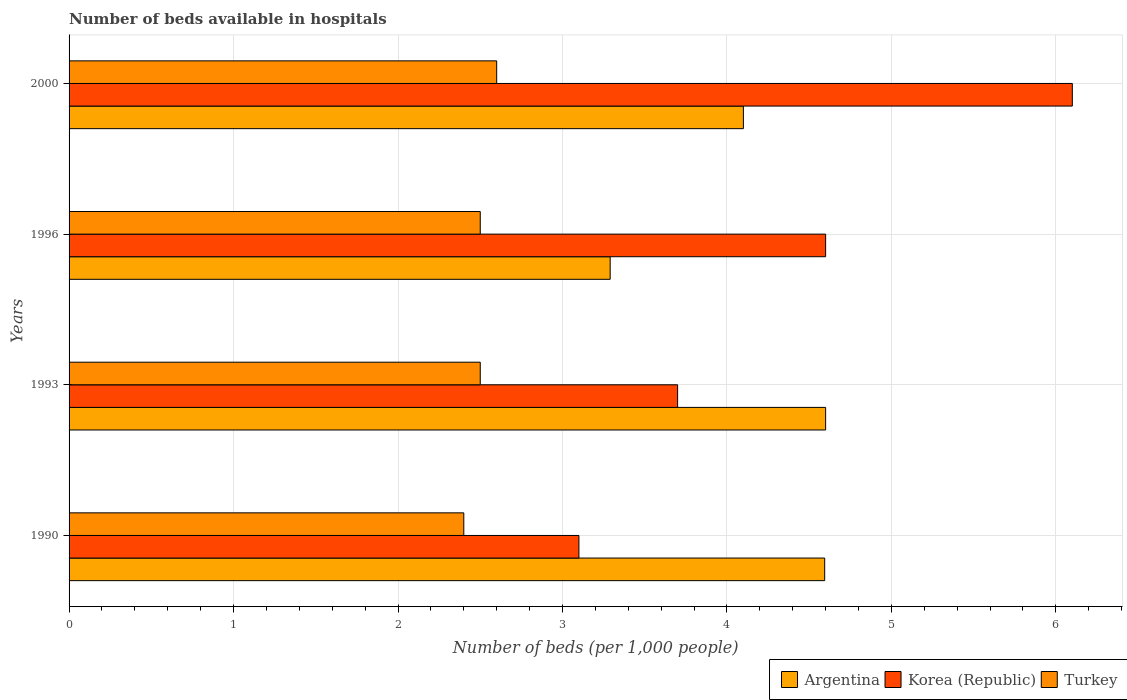Are the number of bars on each tick of the Y-axis equal?
Provide a succinct answer. Yes. How many bars are there on the 2nd tick from the bottom?
Your answer should be compact. 3. What is the label of the 1st group of bars from the top?
Offer a very short reply. 2000. In how many cases, is the number of bars for a given year not equal to the number of legend labels?
Give a very brief answer. 0. What is the number of beds in the hospiatls of in Korea (Republic) in 1993?
Your response must be concise. 3.7. Across all years, what is the maximum number of beds in the hospiatls of in Korea (Republic)?
Give a very brief answer. 6.1. Across all years, what is the minimum number of beds in the hospiatls of in Korea (Republic)?
Offer a very short reply. 3.1. In which year was the number of beds in the hospiatls of in Turkey maximum?
Offer a very short reply. 2000. In which year was the number of beds in the hospiatls of in Turkey minimum?
Offer a terse response. 1990. What is the total number of beds in the hospiatls of in Turkey in the graph?
Your answer should be compact. 10. What is the difference between the number of beds in the hospiatls of in Korea (Republic) in 1993 and that in 2000?
Offer a terse response. -2.4. What is the difference between the number of beds in the hospiatls of in Korea (Republic) in 1993 and the number of beds in the hospiatls of in Turkey in 2000?
Your response must be concise. 1.1. What is the average number of beds in the hospiatls of in Korea (Republic) per year?
Keep it short and to the point. 4.37. In the year 1996, what is the difference between the number of beds in the hospiatls of in Turkey and number of beds in the hospiatls of in Argentina?
Provide a succinct answer. -0.79. In how many years, is the number of beds in the hospiatls of in Argentina greater than 3.8 ?
Keep it short and to the point. 3. What is the ratio of the number of beds in the hospiatls of in Turkey in 1990 to that in 1993?
Your answer should be compact. 0.96. Is the difference between the number of beds in the hospiatls of in Turkey in 1990 and 1993 greater than the difference between the number of beds in the hospiatls of in Argentina in 1990 and 1993?
Ensure brevity in your answer.  No. What is the difference between the highest and the second highest number of beds in the hospiatls of in Korea (Republic)?
Provide a succinct answer. 1.5. What is the difference between the highest and the lowest number of beds in the hospiatls of in Korea (Republic)?
Ensure brevity in your answer.  3. Is the sum of the number of beds in the hospiatls of in Korea (Republic) in 1990 and 1996 greater than the maximum number of beds in the hospiatls of in Argentina across all years?
Your response must be concise. Yes. What does the 3rd bar from the top in 1993 represents?
Offer a very short reply. Argentina. What does the 1st bar from the bottom in 1990 represents?
Provide a succinct answer. Argentina. Is it the case that in every year, the sum of the number of beds in the hospiatls of in Korea (Republic) and number of beds in the hospiatls of in Turkey is greater than the number of beds in the hospiatls of in Argentina?
Provide a succinct answer. Yes. How many bars are there?
Keep it short and to the point. 12. What is the difference between two consecutive major ticks on the X-axis?
Ensure brevity in your answer.  1. Where does the legend appear in the graph?
Provide a short and direct response. Bottom right. How many legend labels are there?
Give a very brief answer. 3. How are the legend labels stacked?
Ensure brevity in your answer.  Horizontal. What is the title of the graph?
Your answer should be compact. Number of beds available in hospitals. Does "United Arab Emirates" appear as one of the legend labels in the graph?
Keep it short and to the point. No. What is the label or title of the X-axis?
Your response must be concise. Number of beds (per 1,0 people). What is the label or title of the Y-axis?
Provide a succinct answer. Years. What is the Number of beds (per 1,000 people) of Argentina in 1990?
Ensure brevity in your answer.  4.59. What is the Number of beds (per 1,000 people) in Korea (Republic) in 1990?
Give a very brief answer. 3.1. What is the Number of beds (per 1,000 people) of Turkey in 1990?
Your response must be concise. 2.4. What is the Number of beds (per 1,000 people) in Argentina in 1993?
Make the answer very short. 4.6. What is the Number of beds (per 1,000 people) of Korea (Republic) in 1993?
Ensure brevity in your answer.  3.7. What is the Number of beds (per 1,000 people) in Argentina in 1996?
Make the answer very short. 3.29. What is the Number of beds (per 1,000 people) of Korea (Republic) in 1996?
Ensure brevity in your answer.  4.6. What is the Number of beds (per 1,000 people) in Turkey in 1996?
Give a very brief answer. 2.5. What is the Number of beds (per 1,000 people) of Korea (Republic) in 2000?
Ensure brevity in your answer.  6.1. What is the Number of beds (per 1,000 people) in Turkey in 2000?
Your answer should be compact. 2.6. Across all years, what is the maximum Number of beds (per 1,000 people) in Argentina?
Your answer should be compact. 4.6. Across all years, what is the maximum Number of beds (per 1,000 people) of Korea (Republic)?
Give a very brief answer. 6.1. Across all years, what is the maximum Number of beds (per 1,000 people) of Turkey?
Your answer should be compact. 2.6. Across all years, what is the minimum Number of beds (per 1,000 people) of Argentina?
Your response must be concise. 3.29. Across all years, what is the minimum Number of beds (per 1,000 people) in Korea (Republic)?
Your answer should be very brief. 3.1. Across all years, what is the minimum Number of beds (per 1,000 people) of Turkey?
Make the answer very short. 2.4. What is the total Number of beds (per 1,000 people) of Argentina in the graph?
Provide a short and direct response. 16.58. What is the difference between the Number of beds (per 1,000 people) in Argentina in 1990 and that in 1993?
Offer a terse response. -0.01. What is the difference between the Number of beds (per 1,000 people) of Korea (Republic) in 1990 and that in 1993?
Provide a succinct answer. -0.6. What is the difference between the Number of beds (per 1,000 people) of Argentina in 1990 and that in 1996?
Your answer should be very brief. 1.3. What is the difference between the Number of beds (per 1,000 people) of Korea (Republic) in 1990 and that in 1996?
Your answer should be compact. -1.5. What is the difference between the Number of beds (per 1,000 people) in Turkey in 1990 and that in 1996?
Provide a short and direct response. -0.1. What is the difference between the Number of beds (per 1,000 people) in Argentina in 1990 and that in 2000?
Ensure brevity in your answer.  0.49. What is the difference between the Number of beds (per 1,000 people) of Argentina in 1993 and that in 1996?
Offer a very short reply. 1.31. What is the difference between the Number of beds (per 1,000 people) in Korea (Republic) in 1993 and that in 1996?
Give a very brief answer. -0.9. What is the difference between the Number of beds (per 1,000 people) in Turkey in 1993 and that in 1996?
Make the answer very short. 0. What is the difference between the Number of beds (per 1,000 people) of Argentina in 1993 and that in 2000?
Ensure brevity in your answer.  0.5. What is the difference between the Number of beds (per 1,000 people) of Korea (Republic) in 1993 and that in 2000?
Keep it short and to the point. -2.4. What is the difference between the Number of beds (per 1,000 people) in Argentina in 1996 and that in 2000?
Your answer should be very brief. -0.81. What is the difference between the Number of beds (per 1,000 people) in Korea (Republic) in 1996 and that in 2000?
Provide a short and direct response. -1.5. What is the difference between the Number of beds (per 1,000 people) of Argentina in 1990 and the Number of beds (per 1,000 people) of Korea (Republic) in 1993?
Offer a very short reply. 0.89. What is the difference between the Number of beds (per 1,000 people) in Argentina in 1990 and the Number of beds (per 1,000 people) in Turkey in 1993?
Offer a very short reply. 2.09. What is the difference between the Number of beds (per 1,000 people) of Argentina in 1990 and the Number of beds (per 1,000 people) of Korea (Republic) in 1996?
Make the answer very short. -0.01. What is the difference between the Number of beds (per 1,000 people) in Argentina in 1990 and the Number of beds (per 1,000 people) in Turkey in 1996?
Make the answer very short. 2.09. What is the difference between the Number of beds (per 1,000 people) in Korea (Republic) in 1990 and the Number of beds (per 1,000 people) in Turkey in 1996?
Offer a very short reply. 0.6. What is the difference between the Number of beds (per 1,000 people) in Argentina in 1990 and the Number of beds (per 1,000 people) in Korea (Republic) in 2000?
Keep it short and to the point. -1.51. What is the difference between the Number of beds (per 1,000 people) in Argentina in 1990 and the Number of beds (per 1,000 people) in Turkey in 2000?
Offer a very short reply. 1.99. What is the difference between the Number of beds (per 1,000 people) in Argentina in 1993 and the Number of beds (per 1,000 people) in Turkey in 1996?
Offer a very short reply. 2.1. What is the difference between the Number of beds (per 1,000 people) in Korea (Republic) in 1993 and the Number of beds (per 1,000 people) in Turkey in 1996?
Your answer should be compact. 1.2. What is the difference between the Number of beds (per 1,000 people) in Argentina in 1993 and the Number of beds (per 1,000 people) in Korea (Republic) in 2000?
Your response must be concise. -1.5. What is the difference between the Number of beds (per 1,000 people) of Korea (Republic) in 1993 and the Number of beds (per 1,000 people) of Turkey in 2000?
Give a very brief answer. 1.1. What is the difference between the Number of beds (per 1,000 people) in Argentina in 1996 and the Number of beds (per 1,000 people) in Korea (Republic) in 2000?
Your response must be concise. -2.81. What is the difference between the Number of beds (per 1,000 people) in Argentina in 1996 and the Number of beds (per 1,000 people) in Turkey in 2000?
Your response must be concise. 0.69. What is the difference between the Number of beds (per 1,000 people) in Korea (Republic) in 1996 and the Number of beds (per 1,000 people) in Turkey in 2000?
Provide a short and direct response. 2. What is the average Number of beds (per 1,000 people) of Argentina per year?
Your answer should be very brief. 4.15. What is the average Number of beds (per 1,000 people) in Korea (Republic) per year?
Make the answer very short. 4.38. In the year 1990, what is the difference between the Number of beds (per 1,000 people) of Argentina and Number of beds (per 1,000 people) of Korea (Republic)?
Provide a short and direct response. 1.49. In the year 1990, what is the difference between the Number of beds (per 1,000 people) of Argentina and Number of beds (per 1,000 people) of Turkey?
Keep it short and to the point. 2.19. In the year 1990, what is the difference between the Number of beds (per 1,000 people) of Korea (Republic) and Number of beds (per 1,000 people) of Turkey?
Make the answer very short. 0.7. In the year 1993, what is the difference between the Number of beds (per 1,000 people) in Argentina and Number of beds (per 1,000 people) in Korea (Republic)?
Provide a succinct answer. 0.9. In the year 1993, what is the difference between the Number of beds (per 1,000 people) in Korea (Republic) and Number of beds (per 1,000 people) in Turkey?
Your answer should be compact. 1.2. In the year 1996, what is the difference between the Number of beds (per 1,000 people) in Argentina and Number of beds (per 1,000 people) in Korea (Republic)?
Make the answer very short. -1.31. In the year 1996, what is the difference between the Number of beds (per 1,000 people) of Argentina and Number of beds (per 1,000 people) of Turkey?
Ensure brevity in your answer.  0.79. In the year 2000, what is the difference between the Number of beds (per 1,000 people) of Argentina and Number of beds (per 1,000 people) of Turkey?
Ensure brevity in your answer.  1.5. In the year 2000, what is the difference between the Number of beds (per 1,000 people) in Korea (Republic) and Number of beds (per 1,000 people) in Turkey?
Make the answer very short. 3.5. What is the ratio of the Number of beds (per 1,000 people) in Korea (Republic) in 1990 to that in 1993?
Your answer should be compact. 0.84. What is the ratio of the Number of beds (per 1,000 people) of Argentina in 1990 to that in 1996?
Give a very brief answer. 1.4. What is the ratio of the Number of beds (per 1,000 people) of Korea (Republic) in 1990 to that in 1996?
Make the answer very short. 0.67. What is the ratio of the Number of beds (per 1,000 people) of Argentina in 1990 to that in 2000?
Your response must be concise. 1.12. What is the ratio of the Number of beds (per 1,000 people) in Korea (Republic) in 1990 to that in 2000?
Offer a terse response. 0.51. What is the ratio of the Number of beds (per 1,000 people) in Argentina in 1993 to that in 1996?
Provide a short and direct response. 1.4. What is the ratio of the Number of beds (per 1,000 people) in Korea (Republic) in 1993 to that in 1996?
Offer a very short reply. 0.8. What is the ratio of the Number of beds (per 1,000 people) of Turkey in 1993 to that in 1996?
Ensure brevity in your answer.  1. What is the ratio of the Number of beds (per 1,000 people) in Argentina in 1993 to that in 2000?
Your answer should be very brief. 1.12. What is the ratio of the Number of beds (per 1,000 people) of Korea (Republic) in 1993 to that in 2000?
Your answer should be compact. 0.61. What is the ratio of the Number of beds (per 1,000 people) in Turkey in 1993 to that in 2000?
Make the answer very short. 0.96. What is the ratio of the Number of beds (per 1,000 people) in Argentina in 1996 to that in 2000?
Offer a terse response. 0.8. What is the ratio of the Number of beds (per 1,000 people) in Korea (Republic) in 1996 to that in 2000?
Offer a terse response. 0.75. What is the ratio of the Number of beds (per 1,000 people) of Turkey in 1996 to that in 2000?
Offer a very short reply. 0.96. What is the difference between the highest and the second highest Number of beds (per 1,000 people) of Argentina?
Provide a short and direct response. 0.01. What is the difference between the highest and the lowest Number of beds (per 1,000 people) in Argentina?
Give a very brief answer. 1.31. What is the difference between the highest and the lowest Number of beds (per 1,000 people) of Turkey?
Your answer should be very brief. 0.2. 